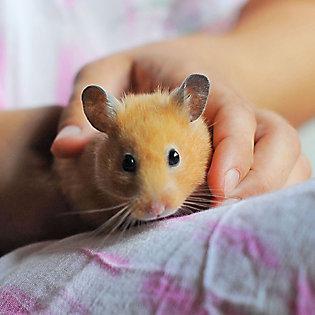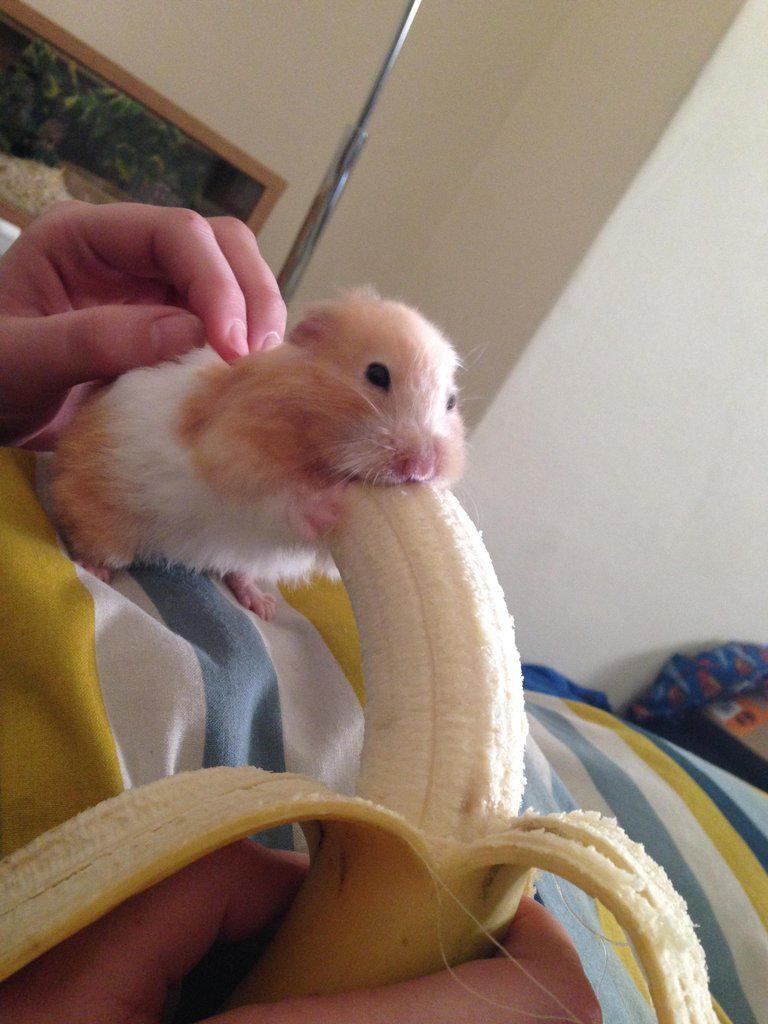The first image is the image on the left, the second image is the image on the right. Given the left and right images, does the statement "There is at least one human hand touching a rodent." hold true? Answer yes or no. Yes. The first image is the image on the left, the second image is the image on the right. Assess this claim about the two images: "An item perforated with a hole is touched by a rodent standing behind it, in one image.". Correct or not? Answer yes or no. No. 